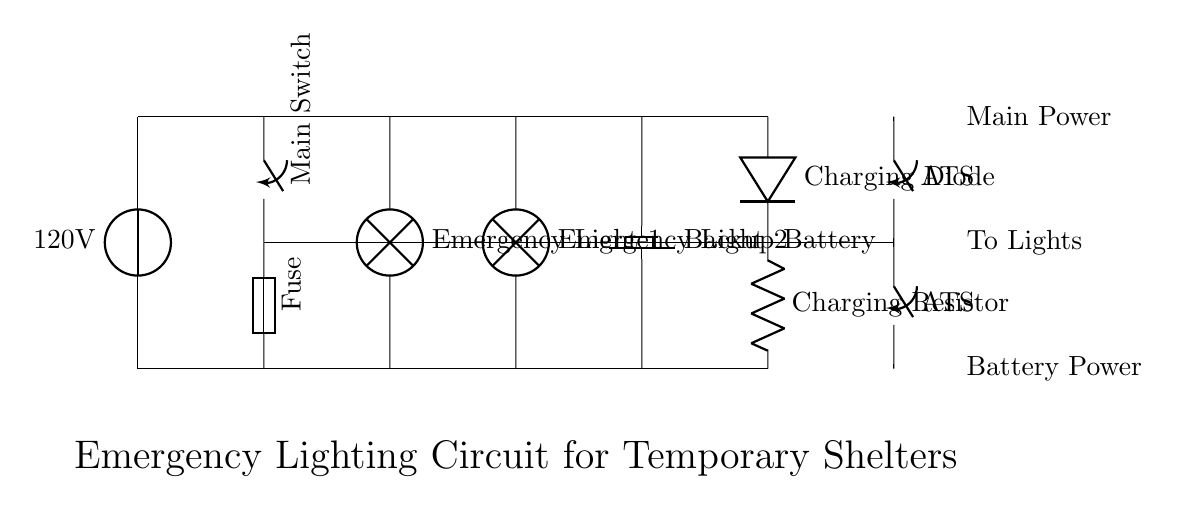What is the main voltage of the circuit? The main voltage is 120 volts, as indicated by the voltage source symbol labeled with this value in the circuit diagram.
Answer: 120 volts What type of switch is used in this circuit? The circuit diagram shows a main switch and an automatic transfer switch, both displayed with the switch symbol. These switches control the flow of current to the lights in different power scenarios.
Answer: Switch How many emergency lights are connected in this circuit? There are two emergency lights shown in the circuit, each represented by lamp symbols connected in parallel.
Answer: Two What component is used to protect the circuit from overload? The fuse is used for protection and is shown in the circuit diagram; it is placed in series with the main power supply to interrupt the current in case of an overload.
Answer: Fuse When the main power is off, which component provides power to the lights? The backup battery provides power to the lights during a mains failure and is connected to the lights through the automatic transfer switch. This switch enables the battery power when the main power is unavailable.
Answer: Backup Battery What prevents current from flowing back into the battery during charging? The charging diode is placed in the circuit to prevent reverse current; it allows current to flow towards the battery but blocks any current that tries to flow back from the battery into the supply source.
Answer: Charging Diode What role does the charging resistor play in the circuit? The charging resistor limits the amount of current flowing to the battery during charging, ensuring it charges safely without overcurrent that could damage the battery.
Answer: Charging Resistor 